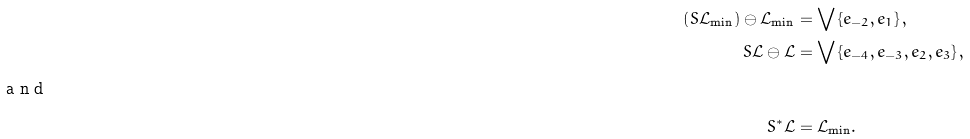Convert formula to latex. <formula><loc_0><loc_0><loc_500><loc_500>\left ( S \mathcal { L } _ { \min } \right ) \ominus \mathcal { L } _ { \min } & = \bigvee \left \{ e _ { - 2 } , e _ { 1 } \right \} , \\ S \mathcal { L \ominus L } & = \bigvee \left \{ e _ { - 4 } , e _ { - 3 } , e _ { 2 } , e _ { 3 } \right \} , \\ \intertext { a n d } S ^ { \ast } \mathcal { L } & = \mathcal { L } _ { \min } .</formula> 